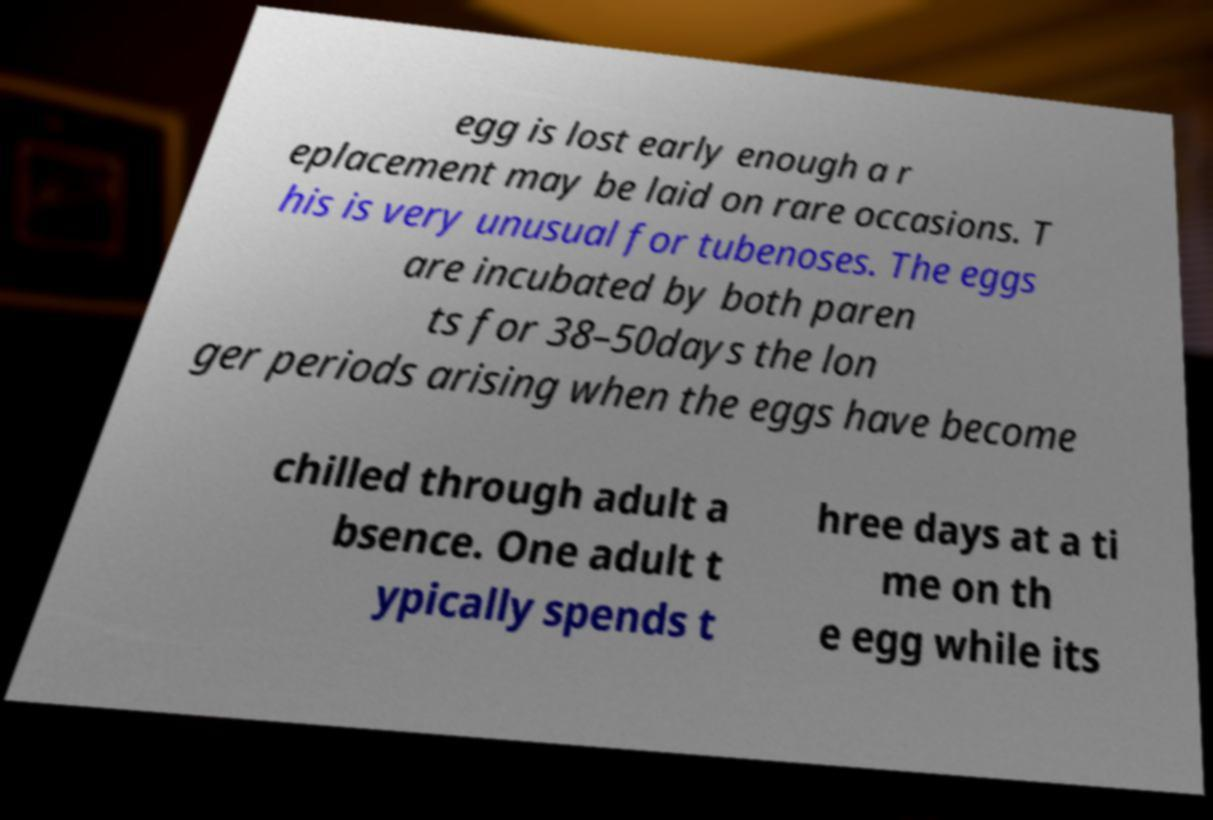There's text embedded in this image that I need extracted. Can you transcribe it verbatim? egg is lost early enough a r eplacement may be laid on rare occasions. T his is very unusual for tubenoses. The eggs are incubated by both paren ts for 38–50days the lon ger periods arising when the eggs have become chilled through adult a bsence. One adult t ypically spends t hree days at a ti me on th e egg while its 